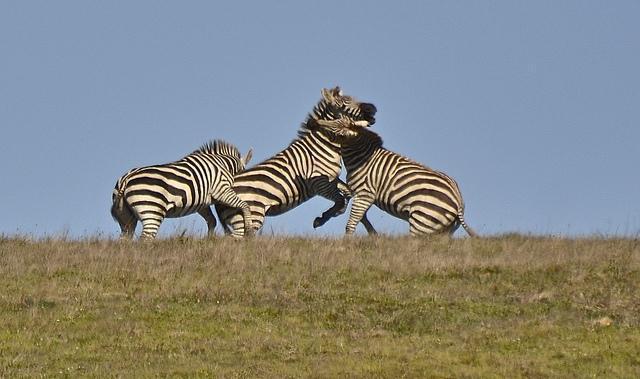How many zebra are standing on their hind legs?
Give a very brief answer. 3. How many zebras are there?
Give a very brief answer. 3. 